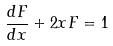Convert formula to latex. <formula><loc_0><loc_0><loc_500><loc_500>\frac { d F } { d x } + 2 x F = 1</formula> 